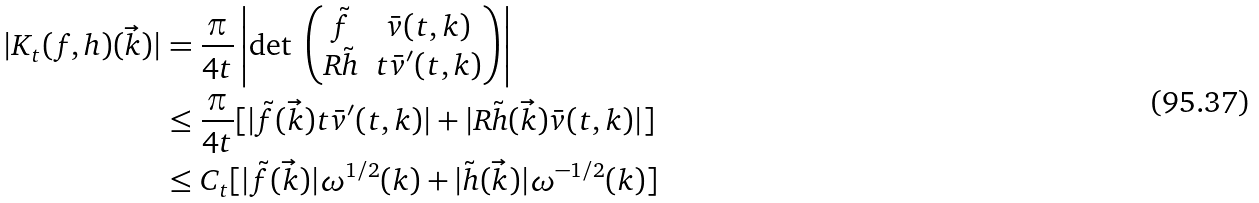<formula> <loc_0><loc_0><loc_500><loc_500>| K _ { t } ( f , h ) ( \vec { k } ) | & = \frac { \pi } { 4 t } \left | \text {det } \begin{pmatrix} \tilde { f } & \bar { v } ( t , k ) \\ R \tilde { h } & t \bar { v } ^ { \prime } ( t , k ) \end{pmatrix} \right | \\ & \leq \frac { \pi } { 4 t } [ | \tilde { f } ( \vec { k } ) t \bar { v } ^ { \prime } ( t , k ) | + | R \tilde { h } ( \vec { k } ) \bar { v } ( t , k ) | ] \\ & \leq C _ { t } [ | \tilde { f } ( \vec { k } ) | \omega ^ { 1 / 2 } ( k ) + | \tilde { h } ( \vec { k } ) | \omega ^ { - 1 / 2 } ( k ) ]</formula> 